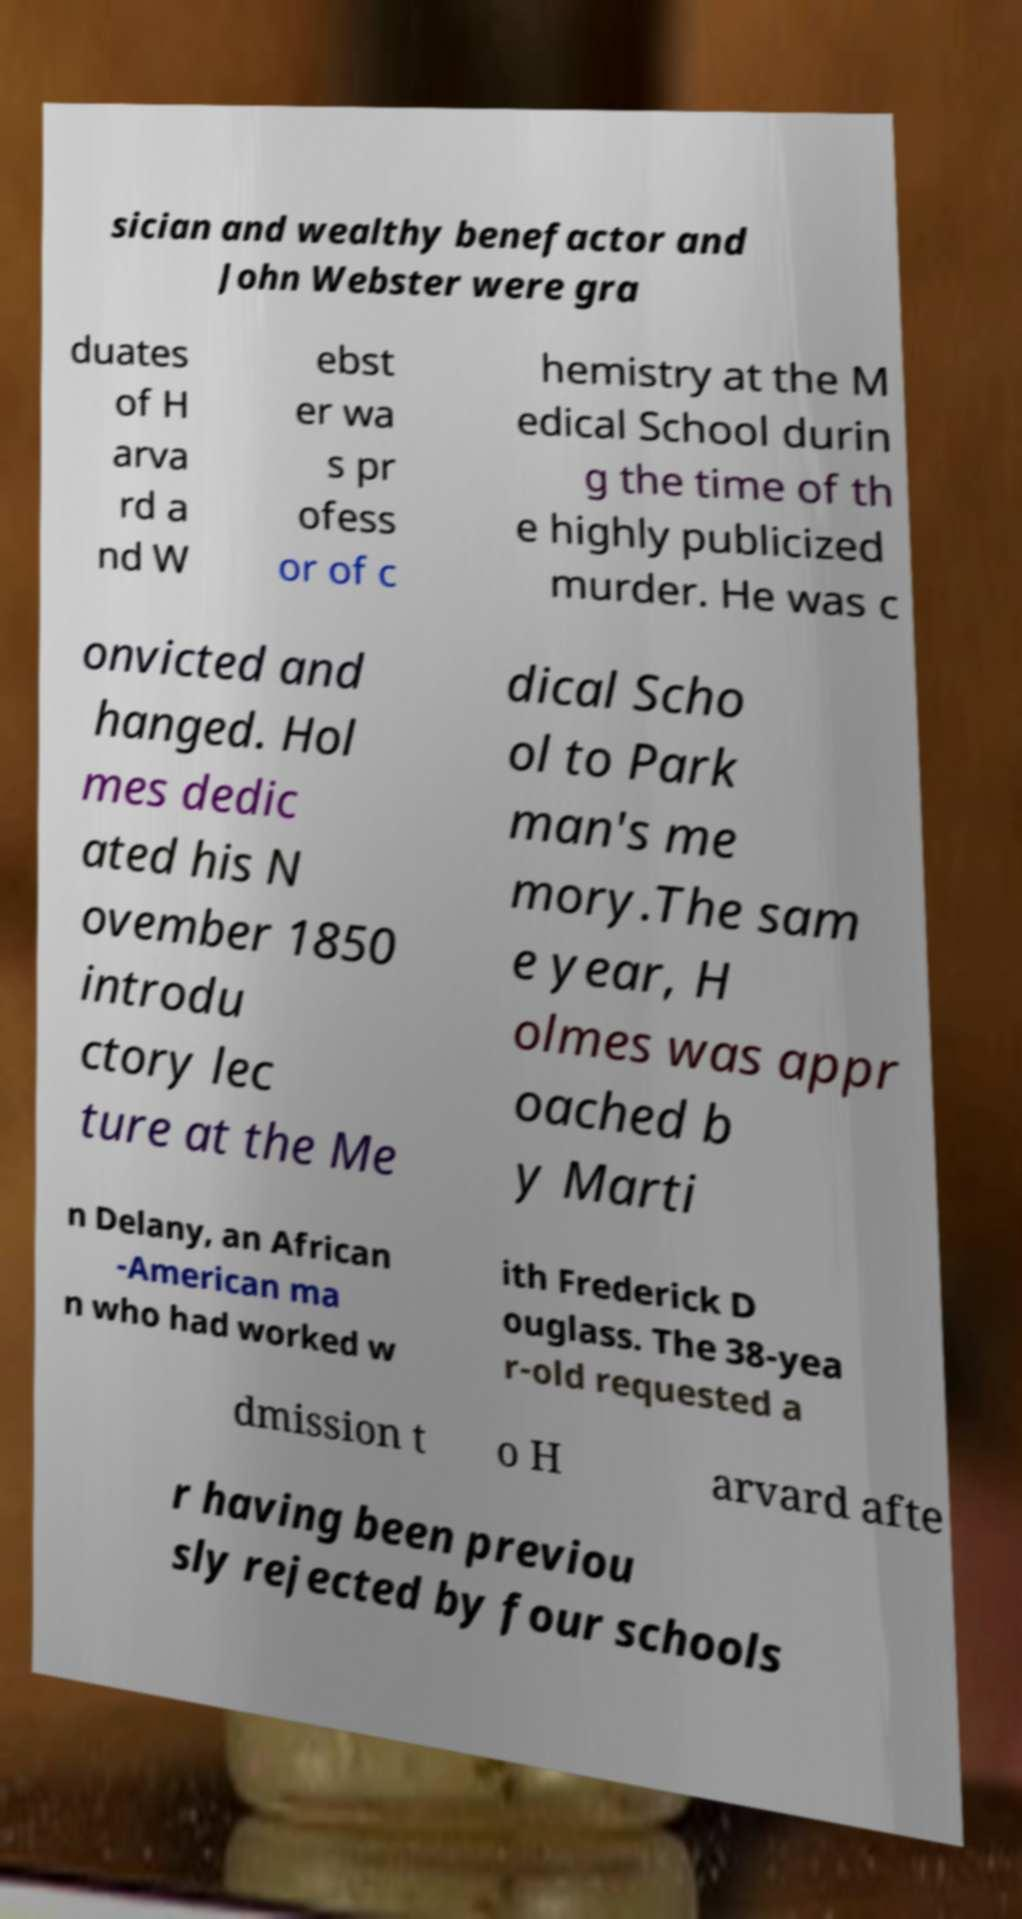There's text embedded in this image that I need extracted. Can you transcribe it verbatim? sician and wealthy benefactor and John Webster were gra duates of H arva rd a nd W ebst er wa s pr ofess or of c hemistry at the M edical School durin g the time of th e highly publicized murder. He was c onvicted and hanged. Hol mes dedic ated his N ovember 1850 introdu ctory lec ture at the Me dical Scho ol to Park man's me mory.The sam e year, H olmes was appr oached b y Marti n Delany, an African -American ma n who had worked w ith Frederick D ouglass. The 38-yea r-old requested a dmission t o H arvard afte r having been previou sly rejected by four schools 